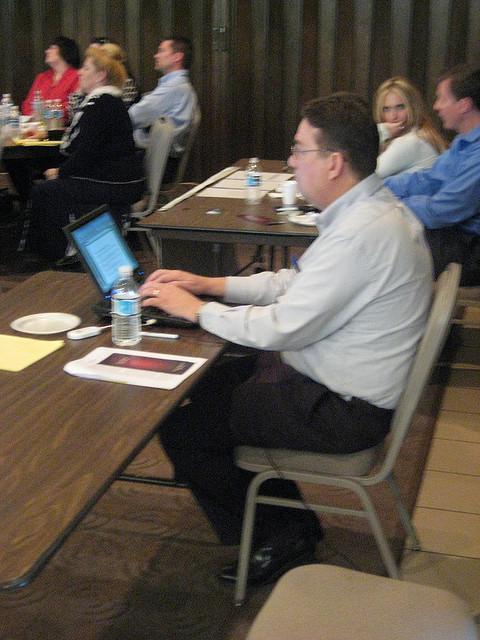How many people can you see?
Give a very brief answer. 6. How many dining tables are visible?
Give a very brief answer. 2. How many chairs can you see?
Give a very brief answer. 3. 